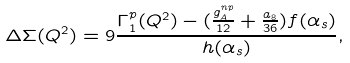<formula> <loc_0><loc_0><loc_500><loc_500>\Delta \Sigma ( Q ^ { 2 } ) = 9 \frac { \Gamma _ { 1 } ^ { p } ( Q ^ { 2 } ) - ( \frac { g _ { A } ^ { n p } } { 1 2 } + \frac { a _ { 8 } } { 3 6 } ) f ( \alpha _ { s } ) } { h ( \alpha _ { s } ) } ,</formula> 